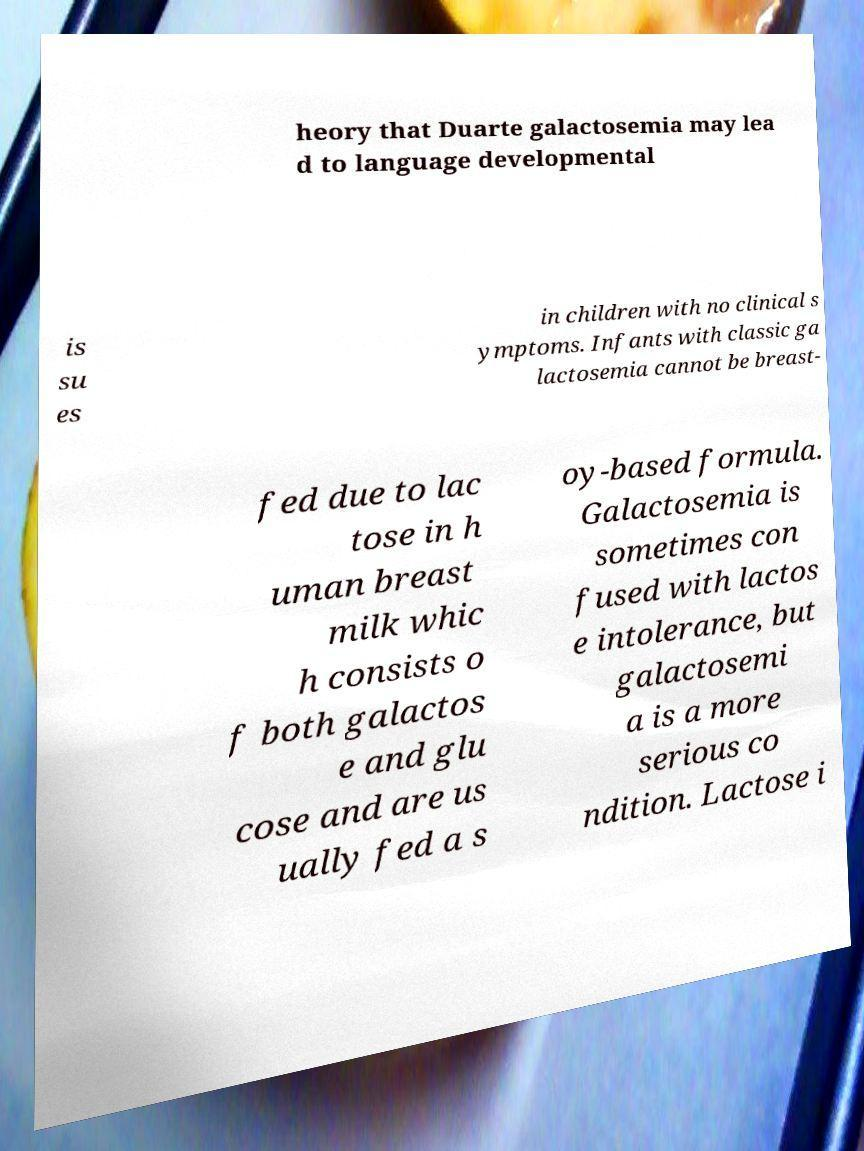Please read and relay the text visible in this image. What does it say? heory that Duarte galactosemia may lea d to language developmental is su es in children with no clinical s ymptoms. Infants with classic ga lactosemia cannot be breast- fed due to lac tose in h uman breast milk whic h consists o f both galactos e and glu cose and are us ually fed a s oy-based formula. Galactosemia is sometimes con fused with lactos e intolerance, but galactosemi a is a more serious co ndition. Lactose i 